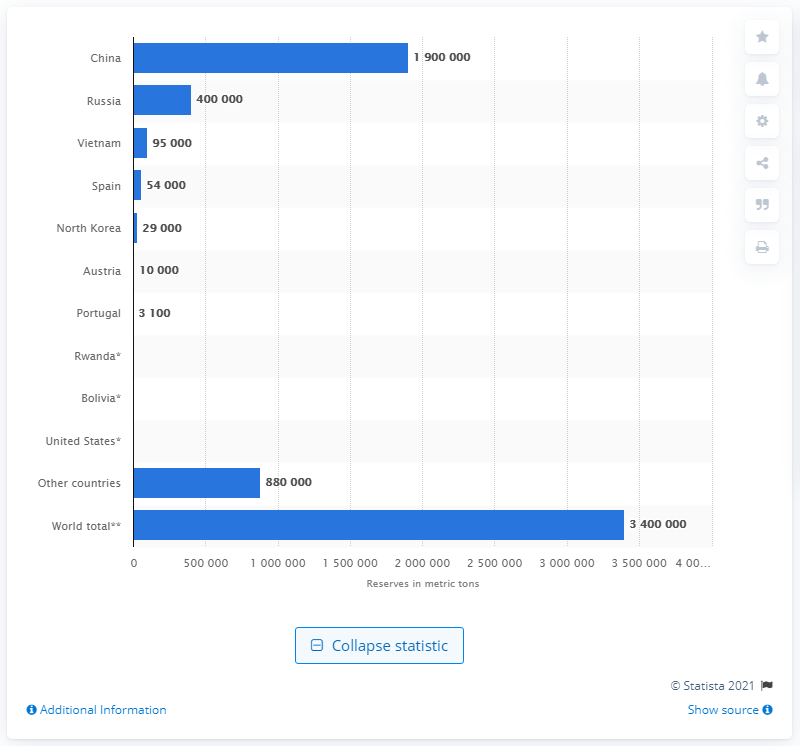Draw attention to some important aspects in this diagram. According to sources, in 2020, China possessed approximately 190,000 metric tons of tungsten, a valuable and versatile resource with a wide range of industrial applications. This significant quantity of tungsten was a testament to China's position as the world's leading producer and consumer of this precious metal. 